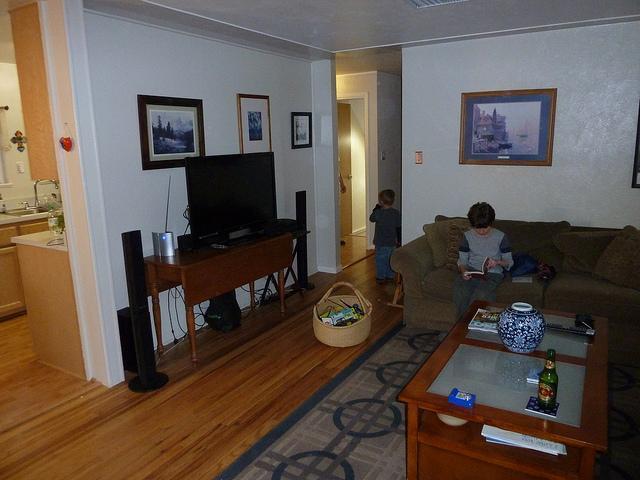How many pictures are on the wall?
Give a very brief answer. 4. How many rooms are shown?
Give a very brief answer. 3. How many inanimate animals are there in the photo?
Give a very brief answer. 0. How many people are there?
Give a very brief answer. 1. 